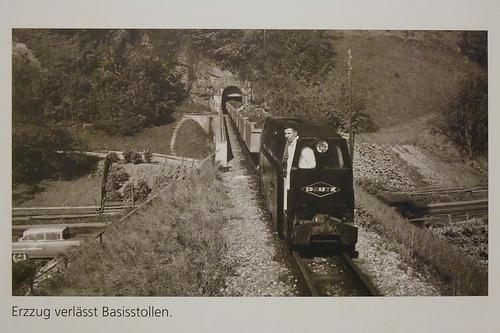How many trains are there?
Give a very brief answer. 1. 